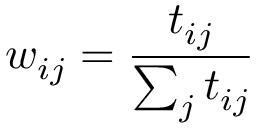<formula> <loc_0><loc_0><loc_500><loc_500>w _ { i j } = \frac { t _ { i j } } { \sum _ { j } t _ { i j } }</formula> 